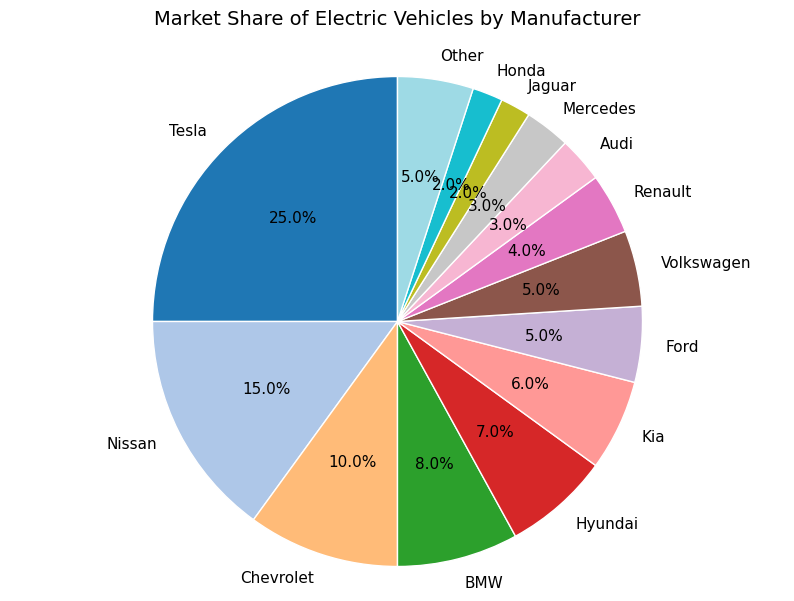What percentage of the market share do the top three manufacturers hold together? Add the market shares of Tesla (25%), Nissan (15%), and Chevrolet (10%) together: 25% + 15% + 10% = 50%
Answer: 50% Which manufacturer has the smallest market share and what is it? Identify the manufacturer with the smallest percentage in the pie chart, which is Jaguar with 2%
Answer: Jaguar, 2% How does the market share of Mercedes compare with that of Audi? Look at the percentages for Mercedes and Audi in the pie chart: both have a market share of 3%
Answer: They are equal What is the total market share of the manufacturers with less than 5% market share each? Add the market shares of BMW (8%), Hyundai (7%), Kia (6%), Ford (5%), Volkswagen (5%), Renault (4%), Audi (3%), Mercedes (3%), Jaguar (2%), and Honda (2%). This is a mistake; only those below 5% should be included: Renault (4%), Audi (3%), Mercedes (3%), Jaguar (2%), and Honda (2%); their sum is 4% + 3% + 3% + 2% + 2% = 14%
Answer: 14% What is the difference between the market share of Tesla and the total market share of Nissan and Chevrolet together? Calculate the total market share of Nissan and Chevrolet: 15% + 10% = 25%, then subtract this from Tesla's market share: 25% - 25% = 0%
Answer: 0% What color represents Ford in the pie chart? Identify the color associated with Ford by visually inspecting the pie chart. (Assume in this case Ford is represented by a specific segment color easy to match from the plot description/code)
Answer: Blue (or the specific segment color) If we consider only Tesla, Nissan, and Chevrolet, what fraction of the market share do they occupy? Add up the market shares of Tesla (25%), Nissan (15%), and Chevrolet (10%): 25% + 15% + 10% = 50%, which means they occupy 50% of the market share. Expressed as a fraction, this is \(\frac{50}{100}\) or simplified as \(\frac{1}{2}\)
Answer: 1/2 How many manufacturers have a market share greater than 5%? Count the number of manufacturers with market shares greater than 5%: Tesla, Nissan, Chevrolet, BMW, Hyundai, and Kia. That’s 6 manufacturers
Answer: 6 